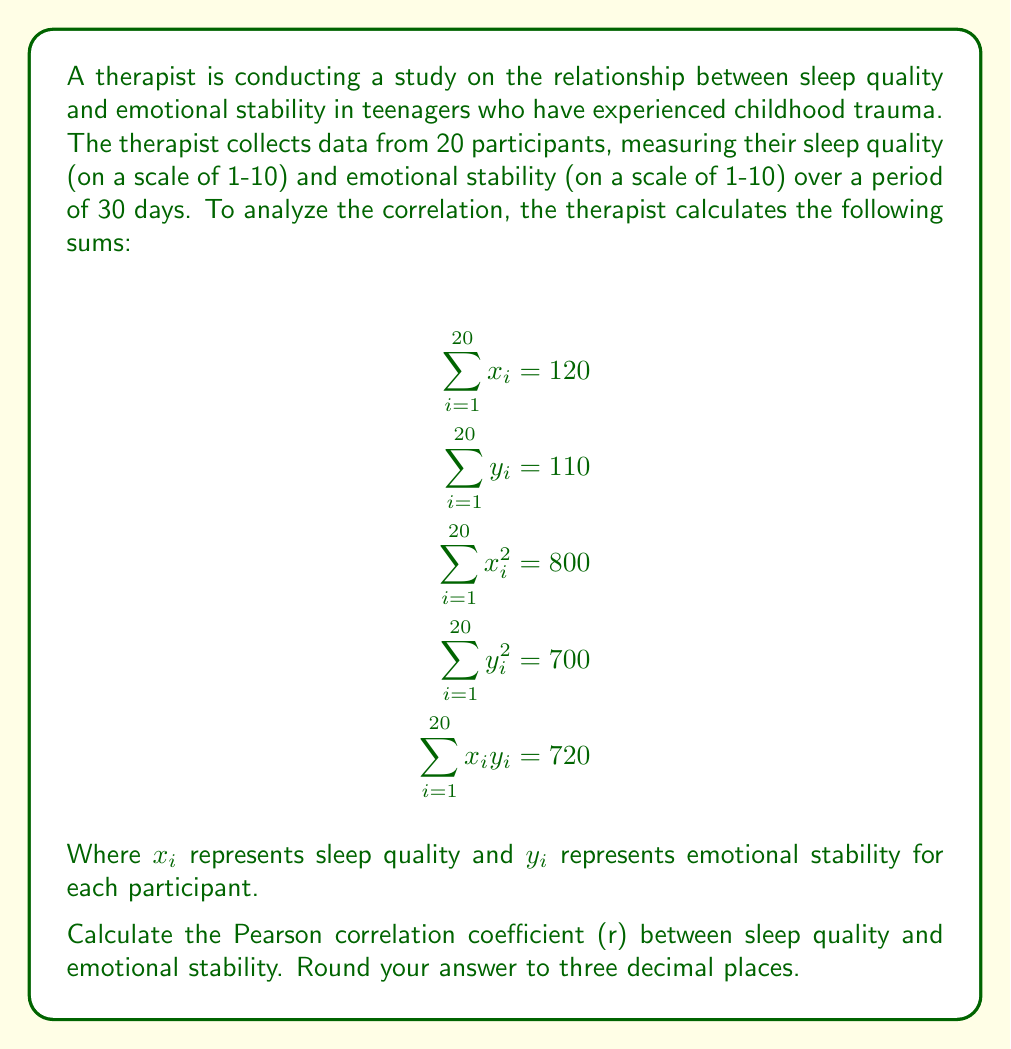Could you help me with this problem? To calculate the Pearson correlation coefficient (r), we'll use the formula:

$$r = \frac{n\sum x_iy_i - \sum x_i \sum y_i}{\sqrt{[n\sum x_i^2 - (\sum x_i)^2][n\sum y_i^2 - (\sum y_i)^2]}}$$

Where n is the number of participants (20 in this case).

Let's substitute the given values:

$$r = \frac{20(720) - (120)(110)}{\sqrt{[20(800) - (120)^2][20(700) - (110)^2]}}$$

Now, let's solve step by step:

1) Calculate the numerator:
   $20(720) - (120)(110) = 14400 - 13200 = 1200$

2) Calculate the first part under the square root:
   $20(800) - (120)^2 = 16000 - 14400 = 1600$

3) Calculate the second part under the square root:
   $20(700) - (110)^2 = 14000 - 12100 = 1900$

4) Multiply the parts under the square root:
   $1600 * 1900 = 3040000$

5) Take the square root:
   $\sqrt{3040000} = 1743.56$ (rounded to 2 decimal places)

6) Divide the numerator by the denominator:
   $1200 / 1743.56 = 0.6882$ (rounded to 4 decimal places)

Therefore, the Pearson correlation coefficient (r) is approximately 0.688.
Answer: 0.688 